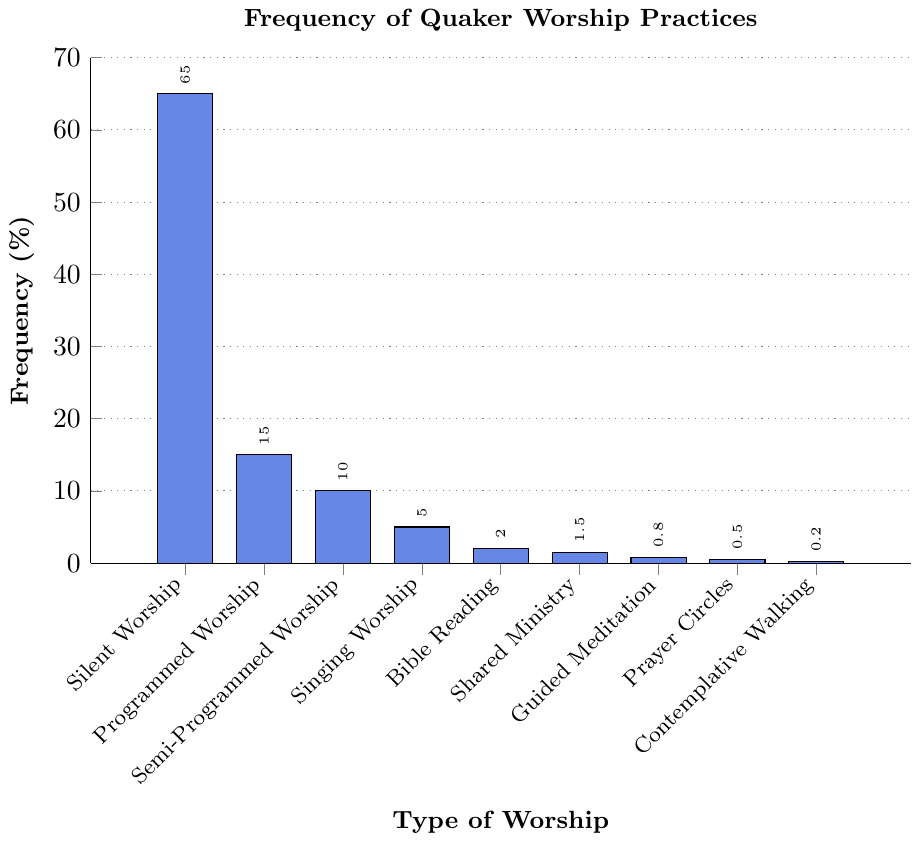Which type of Quaker worship has the highest frequency? The figure shows the frequency in percentages for various types of Quaker worship. The tallest bar represents "Silent Worship" with a frequency of 65%.
Answer: Silent Worship Which type of worship practice has a frequency of 5%? By examining the bars' heights in percentage, the bar labeled "Singing Worship" aligns with the 5% mark on the y-axis.
Answer: Singing Worship How much more frequent is Silent Worship compared to Programmed Worship? The figure indicates Silent Worship at 65% and Programmed Worship at 15%. The difference is 65% - 15% = 50%.
Answer: 50% What is the combined frequency of Semi-Programmed Worship, Bible Reading, and Prayer Circles? Summing the frequencies of Semi-Programmed Worship (10%), Bible Reading (2%), and Prayer Circles (0.5%), gives 10% + 2% + 0.5% = 12.5%.
Answer: 12.5% Which worship practices have a frequency less than 1%? Bars with a frequency below the 1% mark are "Guided Meditation" (0.8%), "Prayer Circles" (0.5%), and "Contemplative Walking" (0.2%).
Answer: Guided Meditation, Prayer Circles, Contemplative Walking What is the difference between the frequency of Shared Ministry and Bible Reading? Shared Ministry has a frequency of 1.5%, and Bible Reading is at 2%. The difference is 2% - 1.5% = 0.5%.
Answer: 0.5% Is the frequency of Programmed Worship greater than the combined frequency of both Singing Worship and Guided Meditation? Programmed Worship is at 15%. Combined frequency of Singing Worship (5%) and Guided Meditation (0.8%) is 5% + 0.8% = 5.8%. Since 15% > 5.8%, the answer is yes.
Answer: Yes Which worship type's frequency is exactly half of Programmed Worship's frequency? Programmed Worship is 15%. The frequency that is half of this is 15% / 2 = 7.5%. No worship type exactly matches this frequency.
Answer: None What percentage of the worship practices have a frequency equal to or greater than 5%? Worship practices with a frequency >= 5% include Silent Worship (65%), Programmed Worship (15%), Semi-Programmed Worship (10%), and Singing Worship (5%). There are 4 out of 9 practices meeting this criterion, so (4/9)*100 ≈ 44.44%.
Answer: 44.44% 